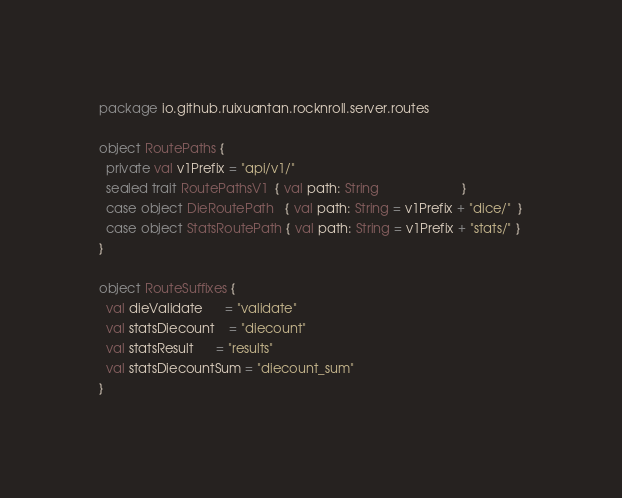<code> <loc_0><loc_0><loc_500><loc_500><_Scala_>package io.github.ruixuantan.rocknroll.server.routes

object RoutePaths {
  private val v1Prefix = "api/v1/"
  sealed trait RoutePathsV1  { val path: String                       }
  case object DieRoutePath   { val path: String = v1Prefix + "dice/"  }
  case object StatsRoutePath { val path: String = v1Prefix + "stats/" }
}

object RouteSuffixes {
  val dieValidate      = "validate"
  val statsDiecount    = "diecount"
  val statsResult      = "results"
  val statsDiecountSum = "diecount_sum"
}
</code> 